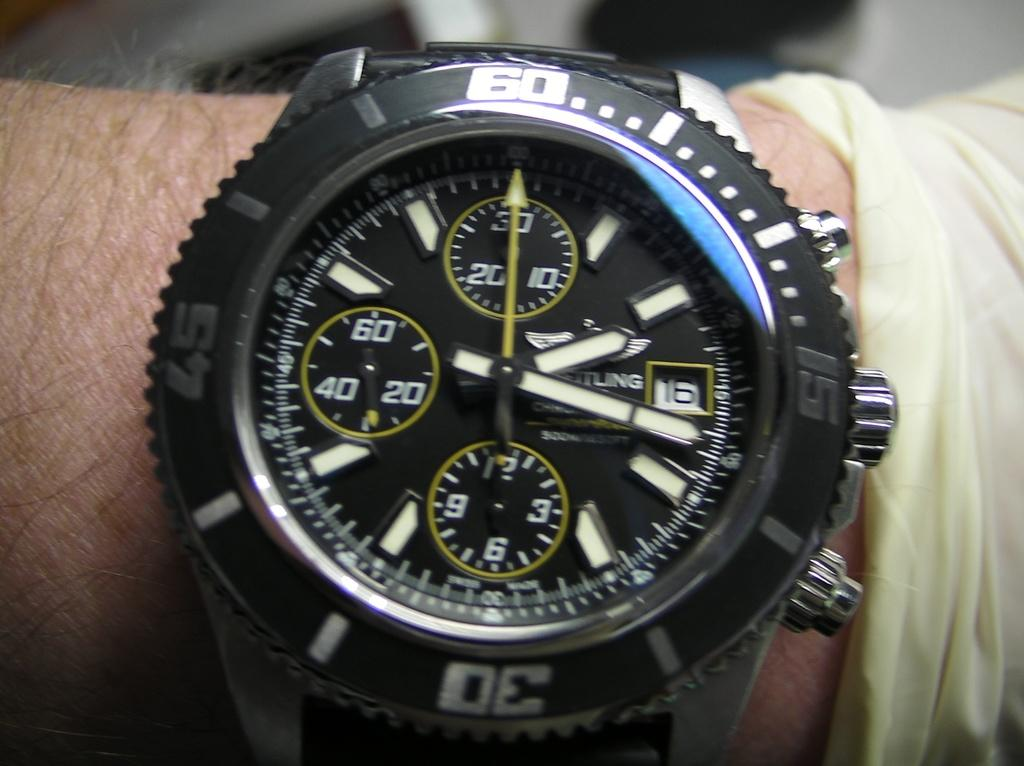What object is visible on a person's hand in the image? There is a watch on a person's hand in the image. What is the color of the watch? The watch is black in color. How many boats are visible in the image? There are no boats present in the image. What type of stem is attached to the watch in the image? The watch in the image does not have a stem, as it is likely a wristwatch. 